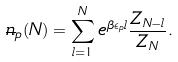Convert formula to latex. <formula><loc_0><loc_0><loc_500><loc_500>\overline { n } _ { p } ( N ) = \sum _ { l = 1 } ^ { N } e ^ { \beta \epsilon _ { p } l } \frac { Z _ { N - l } } { Z _ { N } } .</formula> 